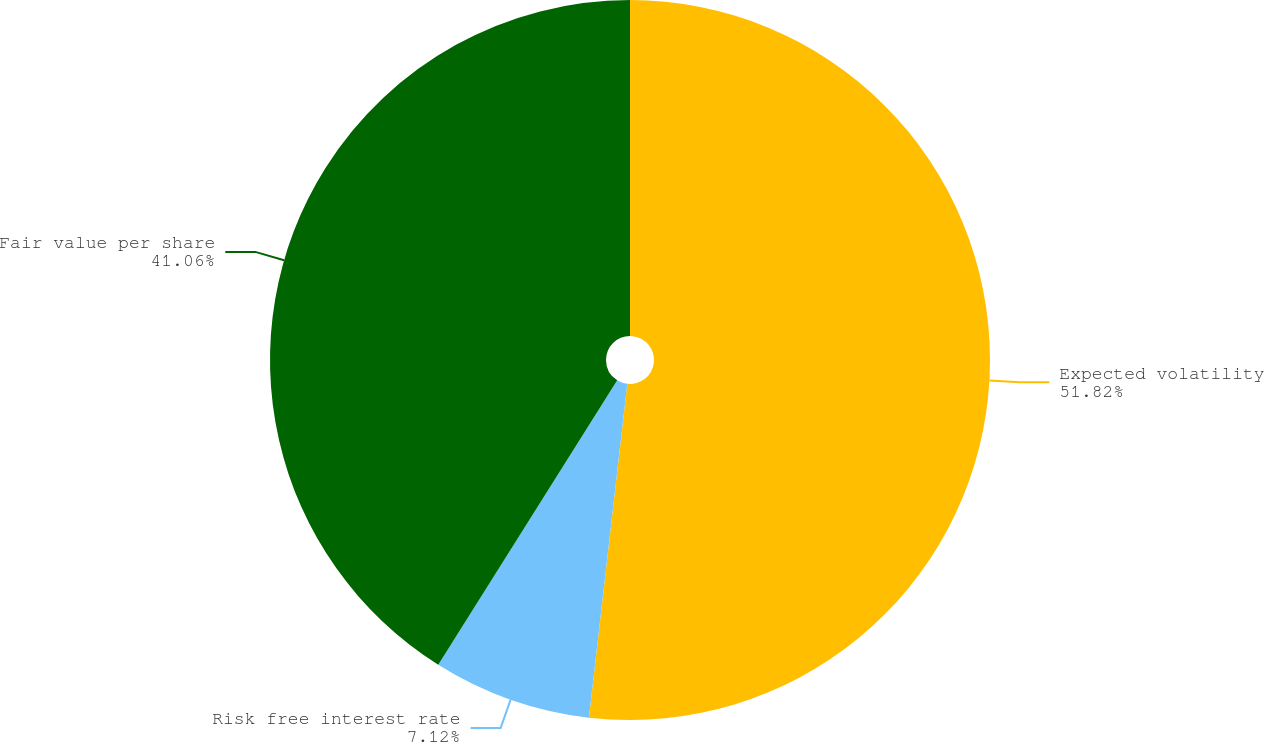Convert chart. <chart><loc_0><loc_0><loc_500><loc_500><pie_chart><fcel>Expected volatility<fcel>Risk free interest rate<fcel>Fair value per share<nl><fcel>51.82%<fcel>7.12%<fcel>41.06%<nl></chart> 